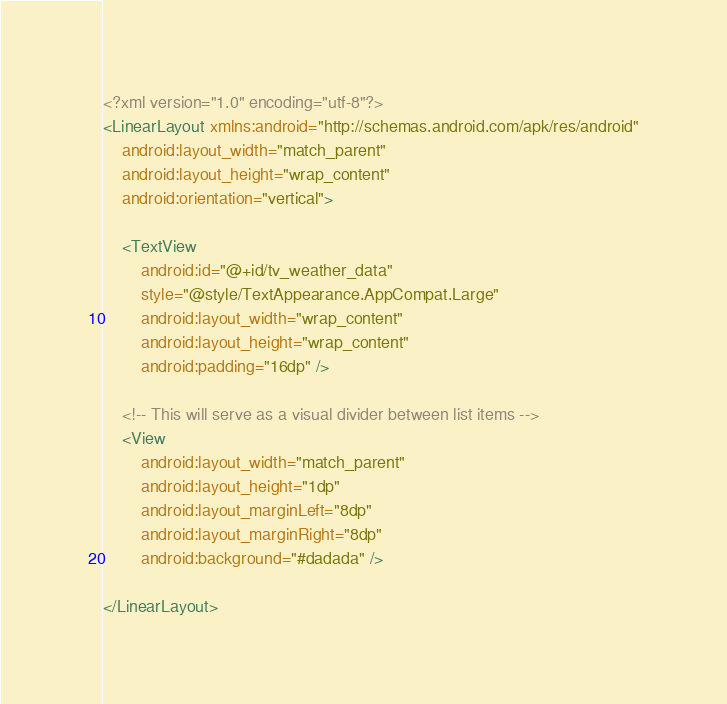<code> <loc_0><loc_0><loc_500><loc_500><_XML_><?xml version="1.0" encoding="utf-8"?>
<LinearLayout xmlns:android="http://schemas.android.com/apk/res/android"
    android:layout_width="match_parent"
    android:layout_height="wrap_content"
    android:orientation="vertical">

    <TextView
        android:id="@+id/tv_weather_data"
        style="@style/TextAppearance.AppCompat.Large"
        android:layout_width="wrap_content"
        android:layout_height="wrap_content"
        android:padding="16dp" />

    <!-- This will serve as a visual divider between list items -->
    <View
        android:layout_width="match_parent"
        android:layout_height="1dp"
        android:layout_marginLeft="8dp"
        android:layout_marginRight="8dp"
        android:background="#dadada" />

</LinearLayout></code> 